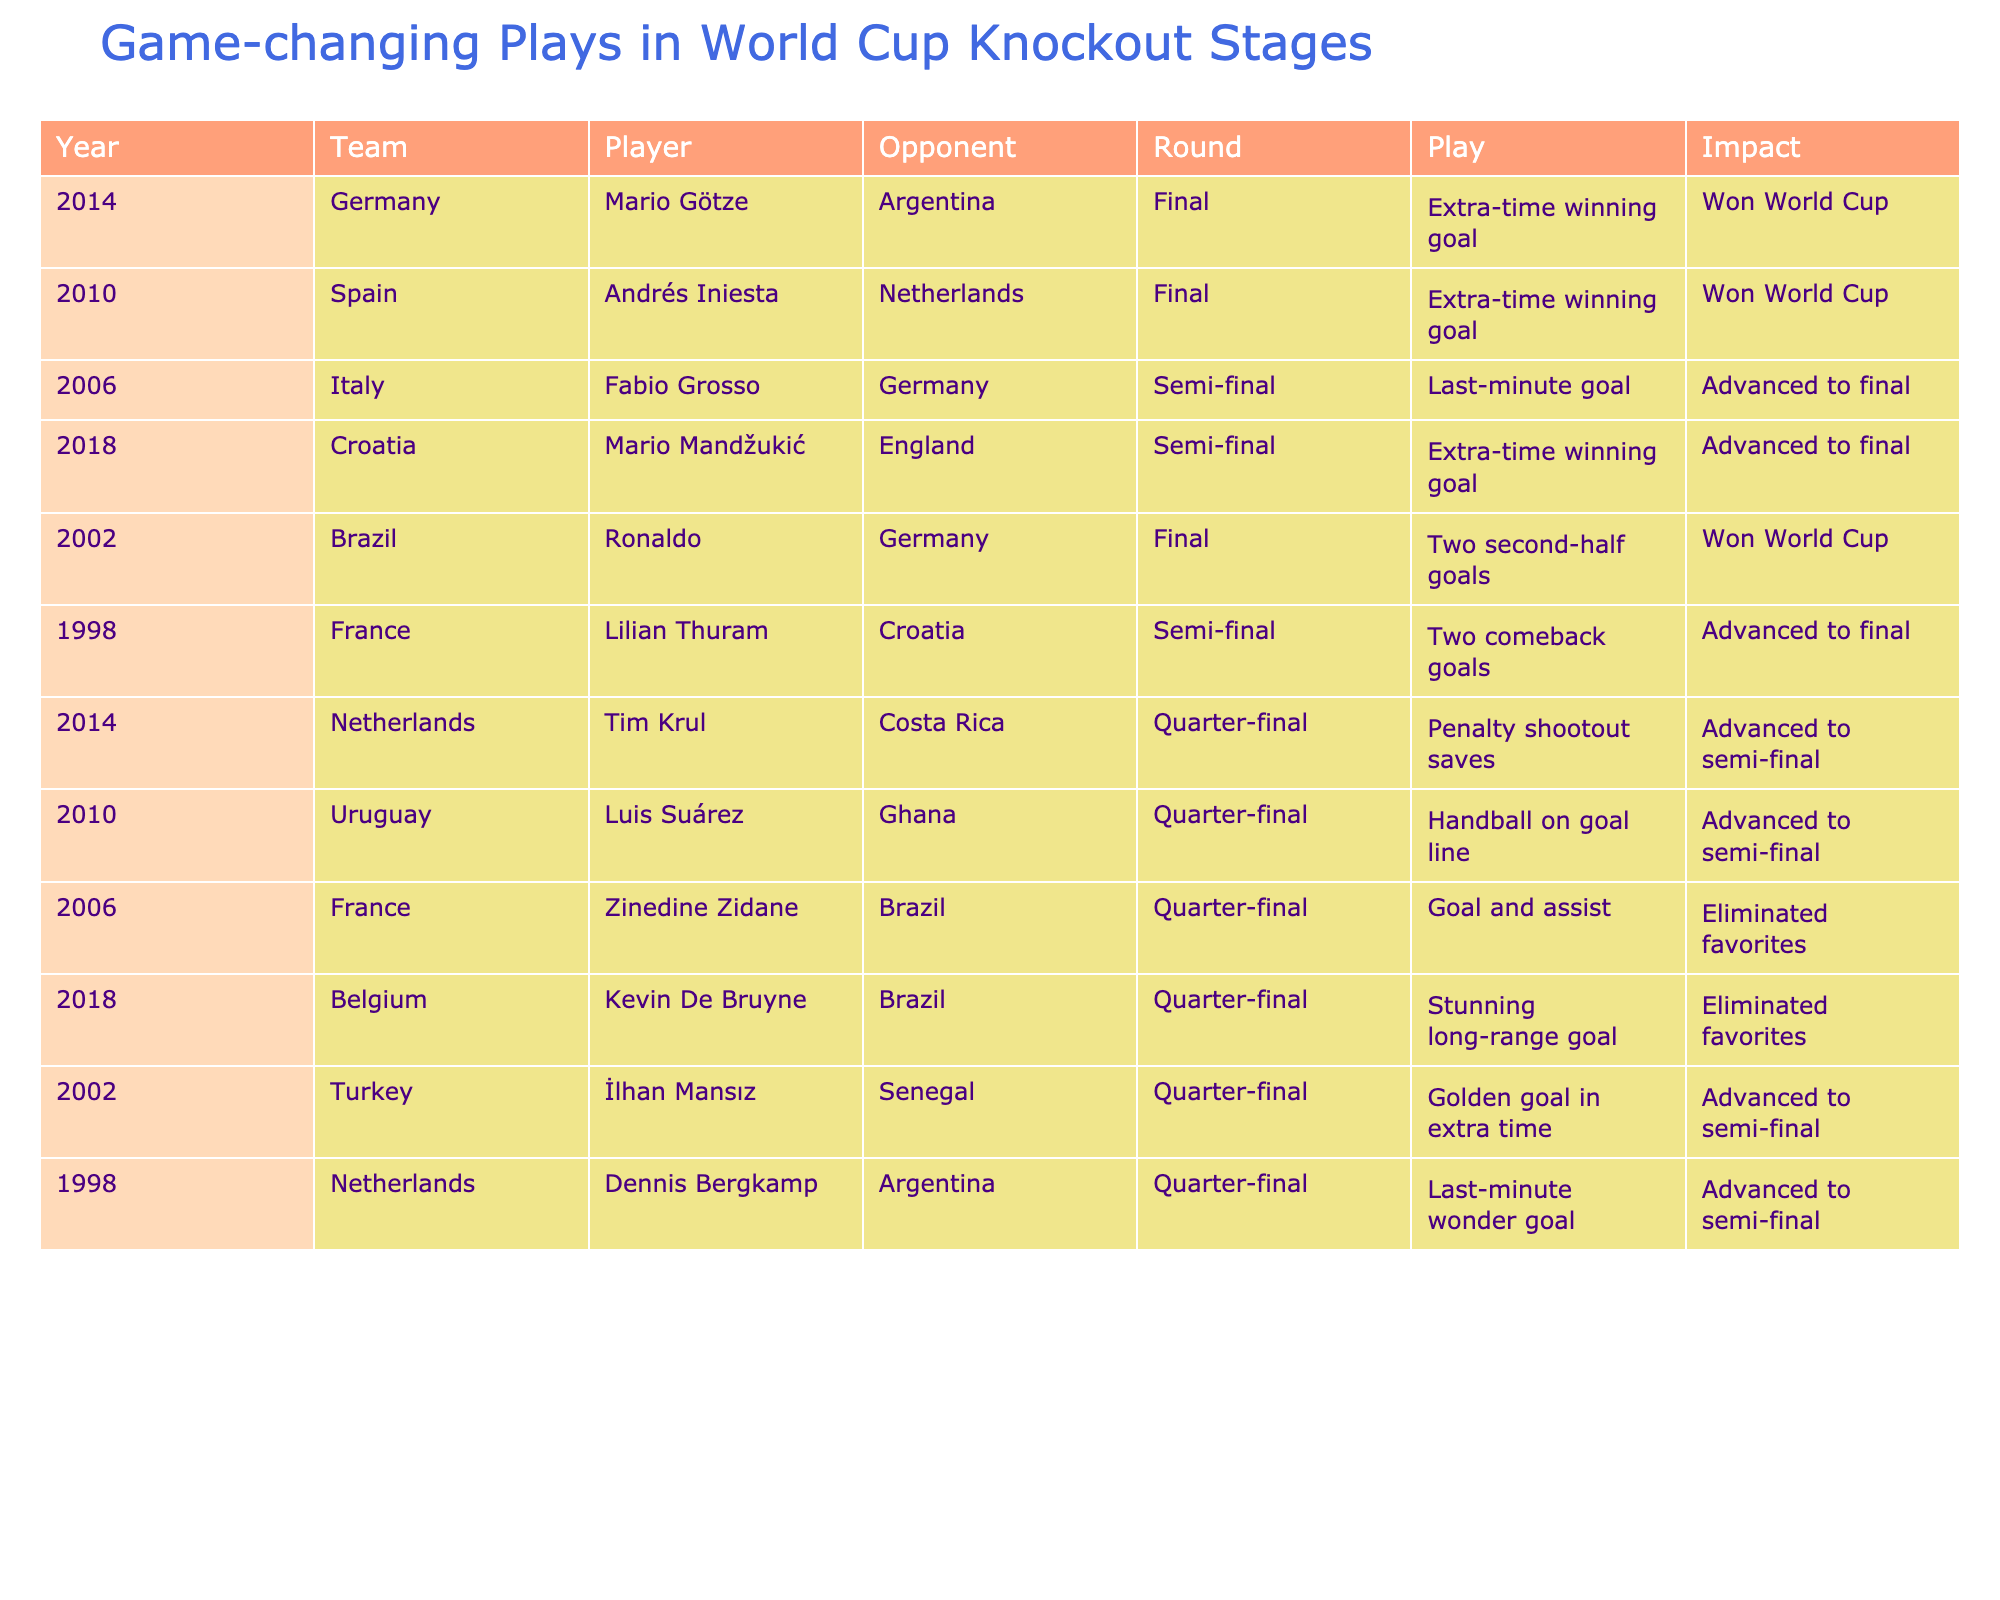What years saw teams win the World Cup with extra-time goals? The table shows the years 2010 (Spain) and 2014 (Germany) where extra-time winning goals resulted in a World Cup victory.
Answer: 2010, 2014 Which player scored a last-minute goal to help their team advance to the final in 2006? The table indicates that Fabio Grosso from Italy scored a last-minute goal against Germany in the 2006 semi-final to help advance to the final.
Answer: Fabio Grosso How many countries advanced to the semi-finals due to a penalty shootout? According to the table, only one country, the Netherlands in 2014, advanced to the semi-finals due to a penalty shootout.
Answer: 1 Did any player score two goals in a World Cup Final? The data confirms that Ronaldo from Brazil scored two goals in the final against Germany in 2002. Thus, the answer is yes.
Answer: Yes Which player's play resulted in eliminating favorites in the 2006 quarter-finals? The table shows that Zinedine Zidane's goal and assist helped France eliminate Brazil, who were considered favorites in the 2006 quarter-finals.
Answer: Zinedine Zidane What is the total number of times extra-time winning goals led to a World Cup victory? By checking the table, one can see that there are two instances of extra-time winning goals leading to World Cup victories: Iniesta in 2010 and Götze in 2014, summing up to a total of 2.
Answer: 2 Which player had a significant impact in the 2018 quarter-finals by scoring a stunning long-range goal? The table indicates that Kevin De Bruyne of Belgium scored a stunning long-range goal against Brazil in the 2018 quarter-finals, which had a significant impact.
Answer: Kevin De Bruyne What was the result of Turkey's İlhan Mansız's play in the 2002 quarter-finals? The table shows that İlhan Mansız scored a golden goal in extra time, allowing Turkey to advance to the semi-finals in 2002.
Answer: Advanced to semi-final How many players contributed to their team's victory by scoring winning goals in the knockout stages? Analyzing the table shows that five players scored winning goals that led to their teams winning (or advancing). The players are Götze, Iniesta, Grosso, Mandžukić, and Ronaldo.
Answer: 5 In which knockout round did both France and Brazil lose to underdogs? According to the table, both France in 2006 (to Italy) and Brazil in 2006 (to France) were eliminated as favorites in the quarter-finals.
Answer: Quarter-finals 